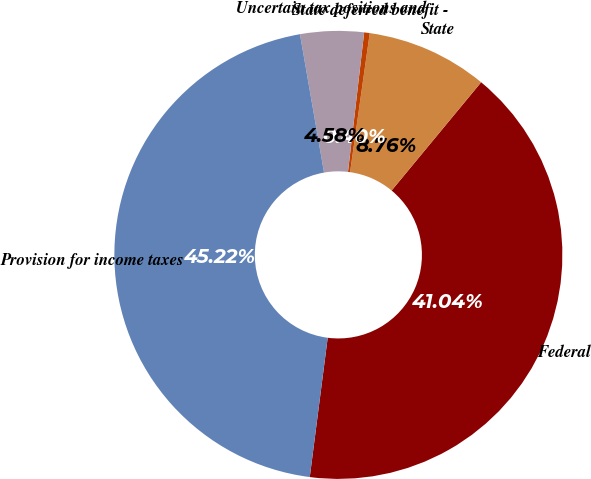Convert chart to OTSL. <chart><loc_0><loc_0><loc_500><loc_500><pie_chart><fcel>Federal<fcel>State<fcel>State deferred benefit -<fcel>Uncertain tax positions and<fcel>Provision for income taxes<nl><fcel>41.04%<fcel>8.76%<fcel>0.4%<fcel>4.58%<fcel>45.22%<nl></chart> 